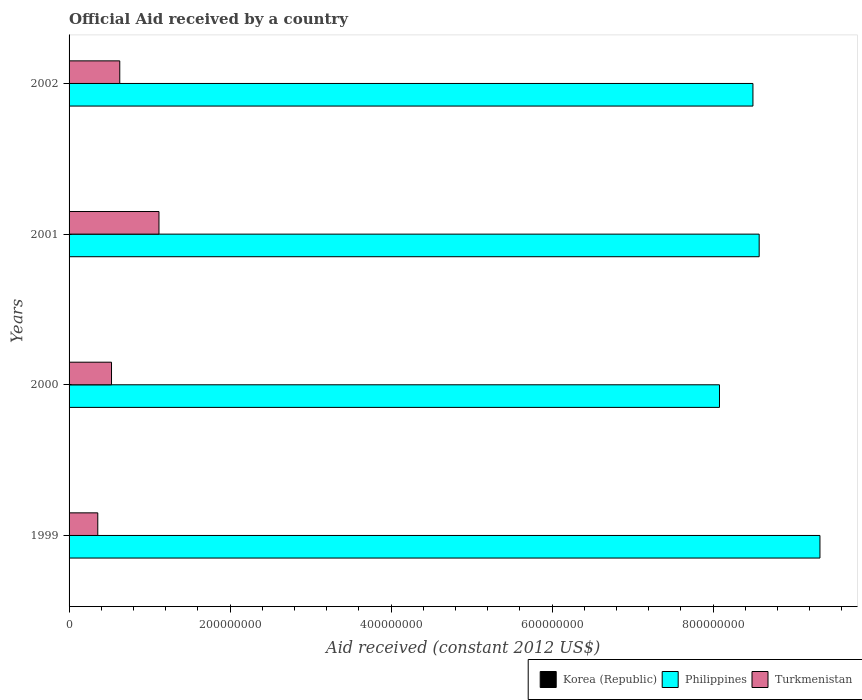Are the number of bars per tick equal to the number of legend labels?
Give a very brief answer. No. Are the number of bars on each tick of the Y-axis equal?
Provide a succinct answer. Yes. What is the label of the 2nd group of bars from the top?
Your response must be concise. 2001. What is the net official aid received in Turkmenistan in 2001?
Give a very brief answer. 1.12e+08. Across all years, what is the maximum net official aid received in Philippines?
Offer a very short reply. 9.33e+08. Across all years, what is the minimum net official aid received in Turkmenistan?
Make the answer very short. 3.57e+07. What is the total net official aid received in Philippines in the graph?
Give a very brief answer. 3.45e+09. What is the difference between the net official aid received in Turkmenistan in 2001 and that in 2002?
Your response must be concise. 4.87e+07. What is the difference between the net official aid received in Turkmenistan in 2001 and the net official aid received in Korea (Republic) in 2002?
Offer a very short reply. 1.12e+08. What is the average net official aid received in Korea (Republic) per year?
Provide a short and direct response. 0. In the year 2001, what is the difference between the net official aid received in Philippines and net official aid received in Turkmenistan?
Your answer should be very brief. 7.46e+08. In how many years, is the net official aid received in Korea (Republic) greater than 440000000 US$?
Ensure brevity in your answer.  0. What is the ratio of the net official aid received in Philippines in 2000 to that in 2002?
Offer a terse response. 0.95. Is the net official aid received in Turkmenistan in 1999 less than that in 2001?
Offer a terse response. Yes. What is the difference between the highest and the second highest net official aid received in Turkmenistan?
Your response must be concise. 4.87e+07. What is the difference between the highest and the lowest net official aid received in Turkmenistan?
Your answer should be very brief. 7.60e+07. How many years are there in the graph?
Ensure brevity in your answer.  4. What is the difference between two consecutive major ticks on the X-axis?
Ensure brevity in your answer.  2.00e+08. Are the values on the major ticks of X-axis written in scientific E-notation?
Your response must be concise. No. Does the graph contain any zero values?
Give a very brief answer. Yes. Does the graph contain grids?
Your response must be concise. No. How many legend labels are there?
Your answer should be compact. 3. How are the legend labels stacked?
Offer a very short reply. Horizontal. What is the title of the graph?
Make the answer very short. Official Aid received by a country. What is the label or title of the X-axis?
Your answer should be compact. Aid received (constant 2012 US$). What is the label or title of the Y-axis?
Give a very brief answer. Years. What is the Aid received (constant 2012 US$) of Philippines in 1999?
Your response must be concise. 9.33e+08. What is the Aid received (constant 2012 US$) of Turkmenistan in 1999?
Your answer should be compact. 3.57e+07. What is the Aid received (constant 2012 US$) in Korea (Republic) in 2000?
Ensure brevity in your answer.  0. What is the Aid received (constant 2012 US$) of Philippines in 2000?
Offer a very short reply. 8.08e+08. What is the Aid received (constant 2012 US$) of Turkmenistan in 2000?
Give a very brief answer. 5.27e+07. What is the Aid received (constant 2012 US$) in Philippines in 2001?
Offer a very short reply. 8.57e+08. What is the Aid received (constant 2012 US$) of Turkmenistan in 2001?
Provide a short and direct response. 1.12e+08. What is the Aid received (constant 2012 US$) of Philippines in 2002?
Offer a terse response. 8.50e+08. What is the Aid received (constant 2012 US$) in Turkmenistan in 2002?
Your answer should be very brief. 6.30e+07. Across all years, what is the maximum Aid received (constant 2012 US$) of Philippines?
Offer a terse response. 9.33e+08. Across all years, what is the maximum Aid received (constant 2012 US$) of Turkmenistan?
Your answer should be compact. 1.12e+08. Across all years, what is the minimum Aid received (constant 2012 US$) of Philippines?
Your answer should be compact. 8.08e+08. Across all years, what is the minimum Aid received (constant 2012 US$) of Turkmenistan?
Offer a terse response. 3.57e+07. What is the total Aid received (constant 2012 US$) of Philippines in the graph?
Your answer should be very brief. 3.45e+09. What is the total Aid received (constant 2012 US$) of Turkmenistan in the graph?
Ensure brevity in your answer.  2.63e+08. What is the difference between the Aid received (constant 2012 US$) in Philippines in 1999 and that in 2000?
Give a very brief answer. 1.25e+08. What is the difference between the Aid received (constant 2012 US$) of Turkmenistan in 1999 and that in 2000?
Give a very brief answer. -1.71e+07. What is the difference between the Aid received (constant 2012 US$) of Philippines in 1999 and that in 2001?
Provide a succinct answer. 7.55e+07. What is the difference between the Aid received (constant 2012 US$) in Turkmenistan in 1999 and that in 2001?
Offer a terse response. -7.60e+07. What is the difference between the Aid received (constant 2012 US$) in Philippines in 1999 and that in 2002?
Your answer should be very brief. 8.32e+07. What is the difference between the Aid received (constant 2012 US$) in Turkmenistan in 1999 and that in 2002?
Your response must be concise. -2.73e+07. What is the difference between the Aid received (constant 2012 US$) of Philippines in 2000 and that in 2001?
Ensure brevity in your answer.  -4.93e+07. What is the difference between the Aid received (constant 2012 US$) of Turkmenistan in 2000 and that in 2001?
Provide a short and direct response. -5.90e+07. What is the difference between the Aid received (constant 2012 US$) in Philippines in 2000 and that in 2002?
Give a very brief answer. -4.16e+07. What is the difference between the Aid received (constant 2012 US$) of Turkmenistan in 2000 and that in 2002?
Keep it short and to the point. -1.02e+07. What is the difference between the Aid received (constant 2012 US$) of Philippines in 2001 and that in 2002?
Give a very brief answer. 7.74e+06. What is the difference between the Aid received (constant 2012 US$) of Turkmenistan in 2001 and that in 2002?
Make the answer very short. 4.87e+07. What is the difference between the Aid received (constant 2012 US$) in Philippines in 1999 and the Aid received (constant 2012 US$) in Turkmenistan in 2000?
Keep it short and to the point. 8.80e+08. What is the difference between the Aid received (constant 2012 US$) in Philippines in 1999 and the Aid received (constant 2012 US$) in Turkmenistan in 2001?
Offer a terse response. 8.21e+08. What is the difference between the Aid received (constant 2012 US$) of Philippines in 1999 and the Aid received (constant 2012 US$) of Turkmenistan in 2002?
Provide a short and direct response. 8.70e+08. What is the difference between the Aid received (constant 2012 US$) of Philippines in 2000 and the Aid received (constant 2012 US$) of Turkmenistan in 2001?
Make the answer very short. 6.96e+08. What is the difference between the Aid received (constant 2012 US$) in Philippines in 2000 and the Aid received (constant 2012 US$) in Turkmenistan in 2002?
Keep it short and to the point. 7.45e+08. What is the difference between the Aid received (constant 2012 US$) of Philippines in 2001 and the Aid received (constant 2012 US$) of Turkmenistan in 2002?
Offer a terse response. 7.94e+08. What is the average Aid received (constant 2012 US$) in Korea (Republic) per year?
Your answer should be very brief. 0. What is the average Aid received (constant 2012 US$) of Philippines per year?
Provide a succinct answer. 8.62e+08. What is the average Aid received (constant 2012 US$) of Turkmenistan per year?
Provide a short and direct response. 6.58e+07. In the year 1999, what is the difference between the Aid received (constant 2012 US$) of Philippines and Aid received (constant 2012 US$) of Turkmenistan?
Keep it short and to the point. 8.97e+08. In the year 2000, what is the difference between the Aid received (constant 2012 US$) of Philippines and Aid received (constant 2012 US$) of Turkmenistan?
Provide a short and direct response. 7.55e+08. In the year 2001, what is the difference between the Aid received (constant 2012 US$) in Philippines and Aid received (constant 2012 US$) in Turkmenistan?
Make the answer very short. 7.46e+08. In the year 2002, what is the difference between the Aid received (constant 2012 US$) of Philippines and Aid received (constant 2012 US$) of Turkmenistan?
Keep it short and to the point. 7.87e+08. What is the ratio of the Aid received (constant 2012 US$) of Philippines in 1999 to that in 2000?
Your response must be concise. 1.15. What is the ratio of the Aid received (constant 2012 US$) in Turkmenistan in 1999 to that in 2000?
Provide a succinct answer. 0.68. What is the ratio of the Aid received (constant 2012 US$) in Philippines in 1999 to that in 2001?
Your response must be concise. 1.09. What is the ratio of the Aid received (constant 2012 US$) in Turkmenistan in 1999 to that in 2001?
Give a very brief answer. 0.32. What is the ratio of the Aid received (constant 2012 US$) of Philippines in 1999 to that in 2002?
Your response must be concise. 1.1. What is the ratio of the Aid received (constant 2012 US$) of Turkmenistan in 1999 to that in 2002?
Offer a very short reply. 0.57. What is the ratio of the Aid received (constant 2012 US$) of Philippines in 2000 to that in 2001?
Provide a succinct answer. 0.94. What is the ratio of the Aid received (constant 2012 US$) of Turkmenistan in 2000 to that in 2001?
Give a very brief answer. 0.47. What is the ratio of the Aid received (constant 2012 US$) of Philippines in 2000 to that in 2002?
Ensure brevity in your answer.  0.95. What is the ratio of the Aid received (constant 2012 US$) in Turkmenistan in 2000 to that in 2002?
Your answer should be very brief. 0.84. What is the ratio of the Aid received (constant 2012 US$) of Philippines in 2001 to that in 2002?
Offer a very short reply. 1.01. What is the ratio of the Aid received (constant 2012 US$) in Turkmenistan in 2001 to that in 2002?
Provide a short and direct response. 1.77. What is the difference between the highest and the second highest Aid received (constant 2012 US$) in Philippines?
Your answer should be compact. 7.55e+07. What is the difference between the highest and the second highest Aid received (constant 2012 US$) in Turkmenistan?
Make the answer very short. 4.87e+07. What is the difference between the highest and the lowest Aid received (constant 2012 US$) of Philippines?
Your answer should be compact. 1.25e+08. What is the difference between the highest and the lowest Aid received (constant 2012 US$) in Turkmenistan?
Your response must be concise. 7.60e+07. 